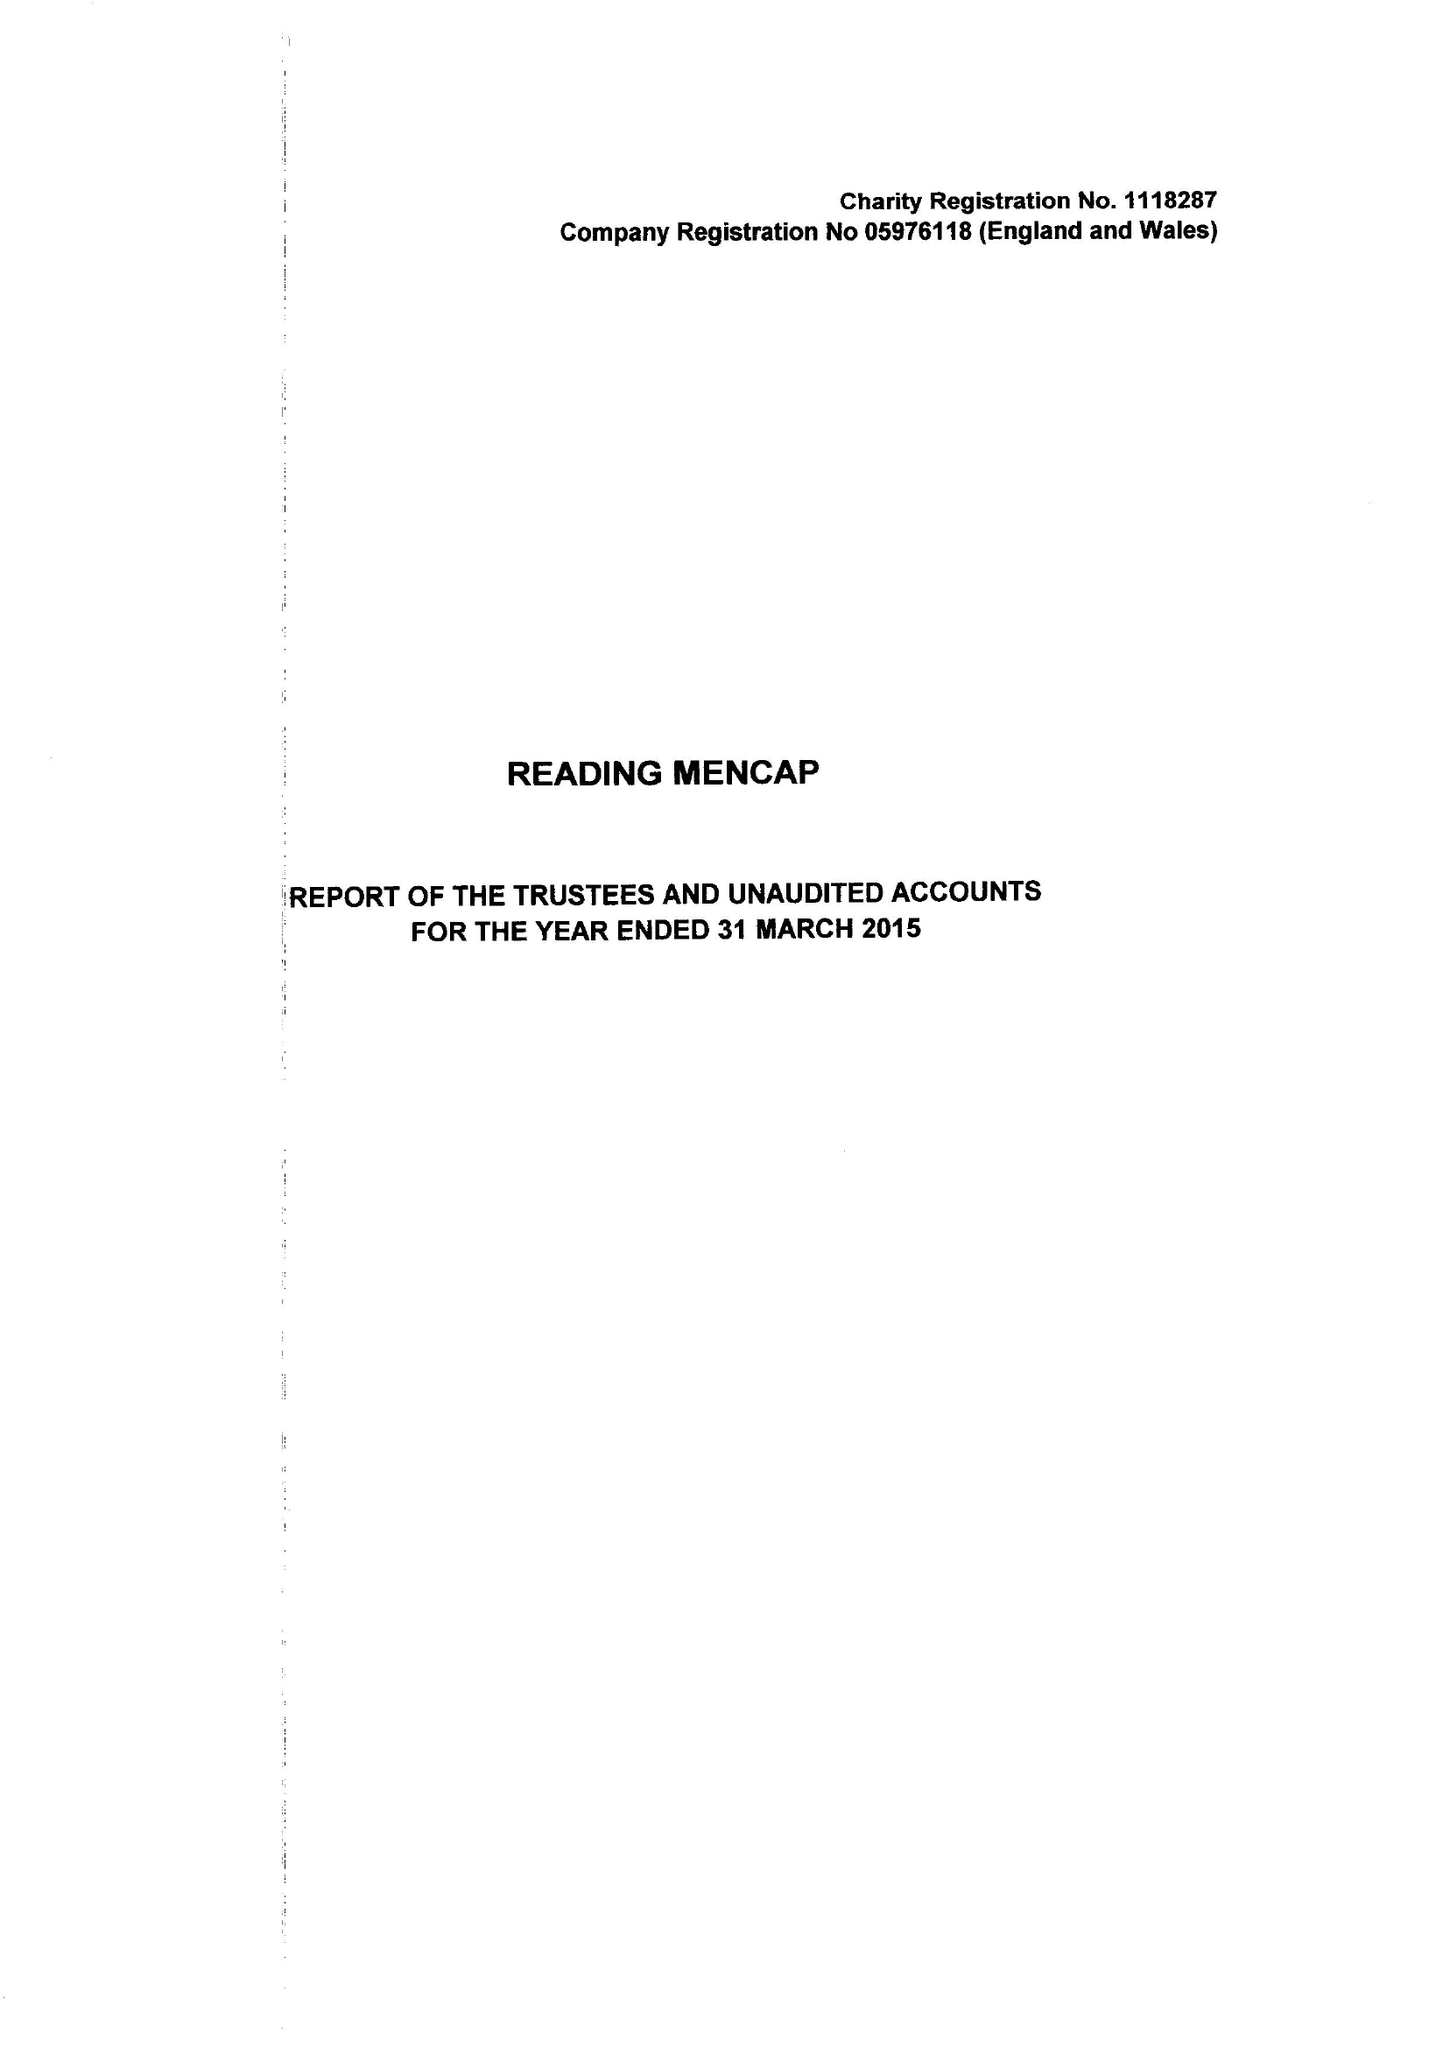What is the value for the address__postcode?
Answer the question using a single word or phrase. RG1 5PE 